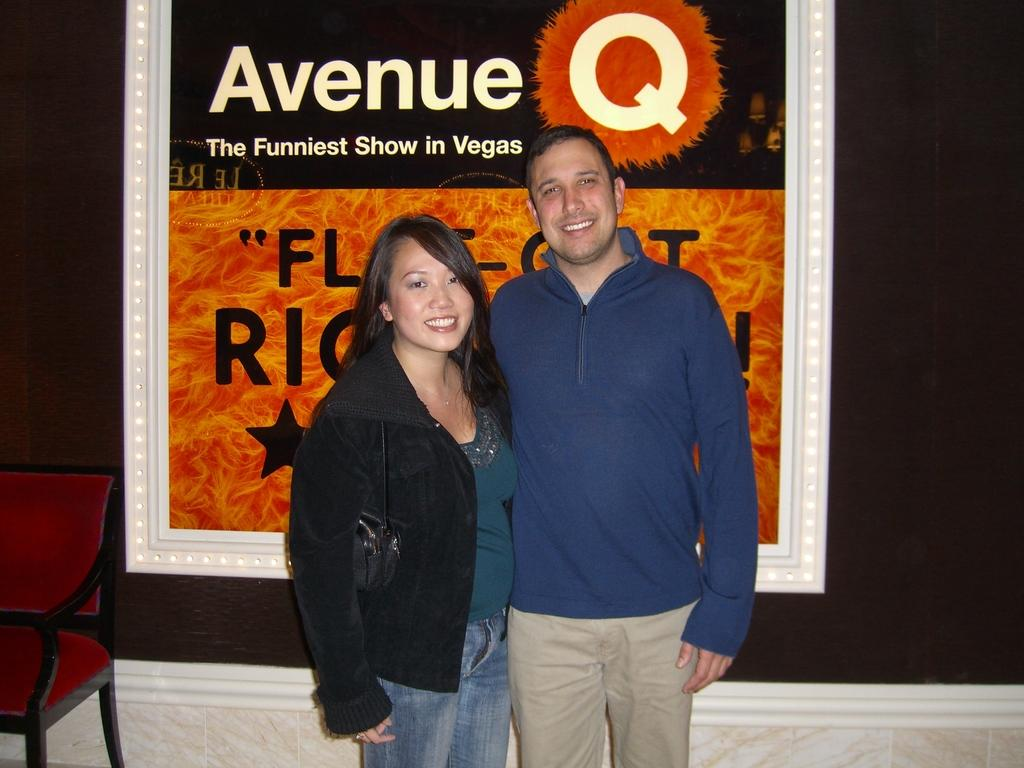Who is present in the image? There is a woman and a man in the image. What are the expressions on their faces? Both the woman and the man are smiling in the image. What surface are they standing on? They are standing on the floor. What can be seen in the background of the image? There is a chair and a wall in the background of the image. How many apples are being used to alleviate the pain in the image? There are no apples or references to pain present in the image. 